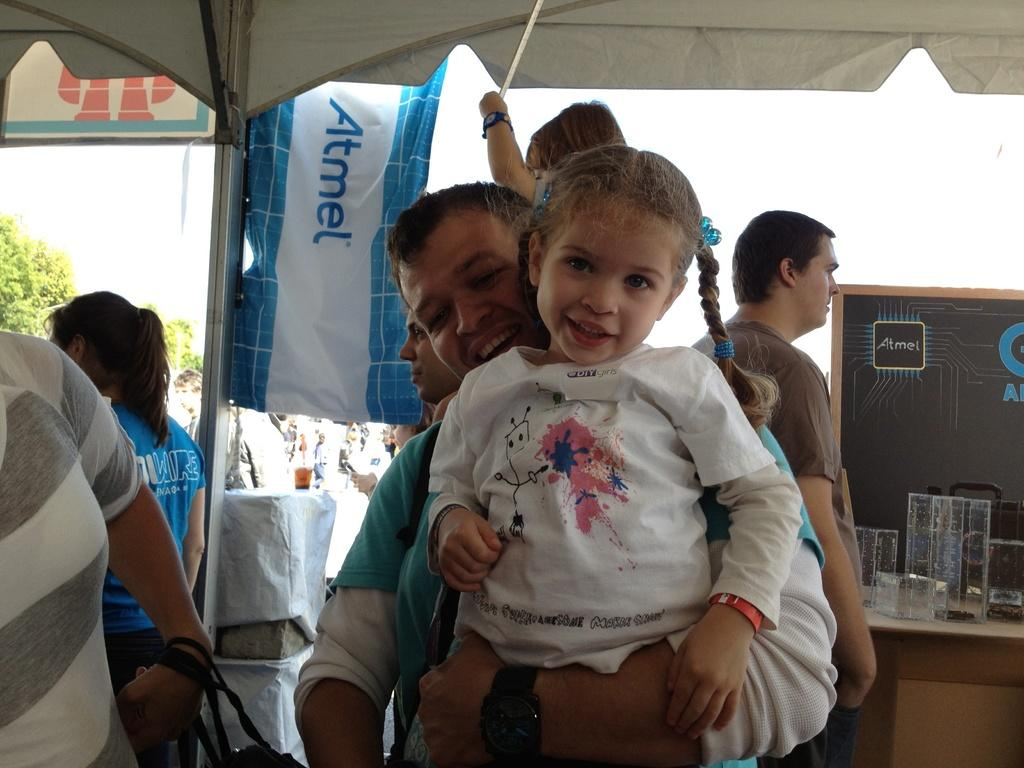Who or what can be seen in the image? There are people in the image. What object is located on the right side of the image? There is a table on the right side of the image. What items are on the table? There are glasses on the table. What is at the top of the image? There is a cloth at the top of the image. What type of natural environment is visible in the image? There are trees and sky visible in the image. What type of throne is visible in the image? There is no throne present in the image. What things are being discussed by the people in the image? The image does not provide any information about a discussion or the topics being discussed. 